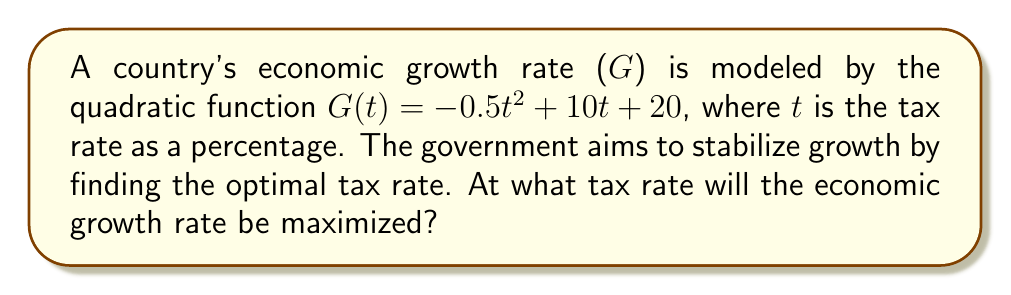Show me your answer to this math problem. To find the optimal tax rate that maximizes economic growth, we need to determine the vertex of the quadratic function. The vertex represents the maximum point of the parabola, given that the coefficient of $t^2$ is negative (indicating the parabola opens downward).

For a quadratic function in the form $f(x) = ax^2 + bx + c$, the x-coordinate of the vertex is given by $x = -\frac{b}{2a}$.

In our case:
$a = -0.5$
$b = 10$
$c = 20$

Plugging these values into the formula:

$t = -\frac{10}{2(-0.5)} = -\frac{10}{-1} = 10$

To verify this is indeed a maximum, we can calculate the discriminant:
$b^2 - 4ac = 10^2 - 4(-0.5)(20) = 100 + 40 = 140 > 0$

Since the discriminant is positive and $a$ is negative, this confirms we have a maximum.

Therefore, the economic growth rate will be maximized when the tax rate is 10%.
Answer: The optimal tax rate to maximize economic growth is 10%. 